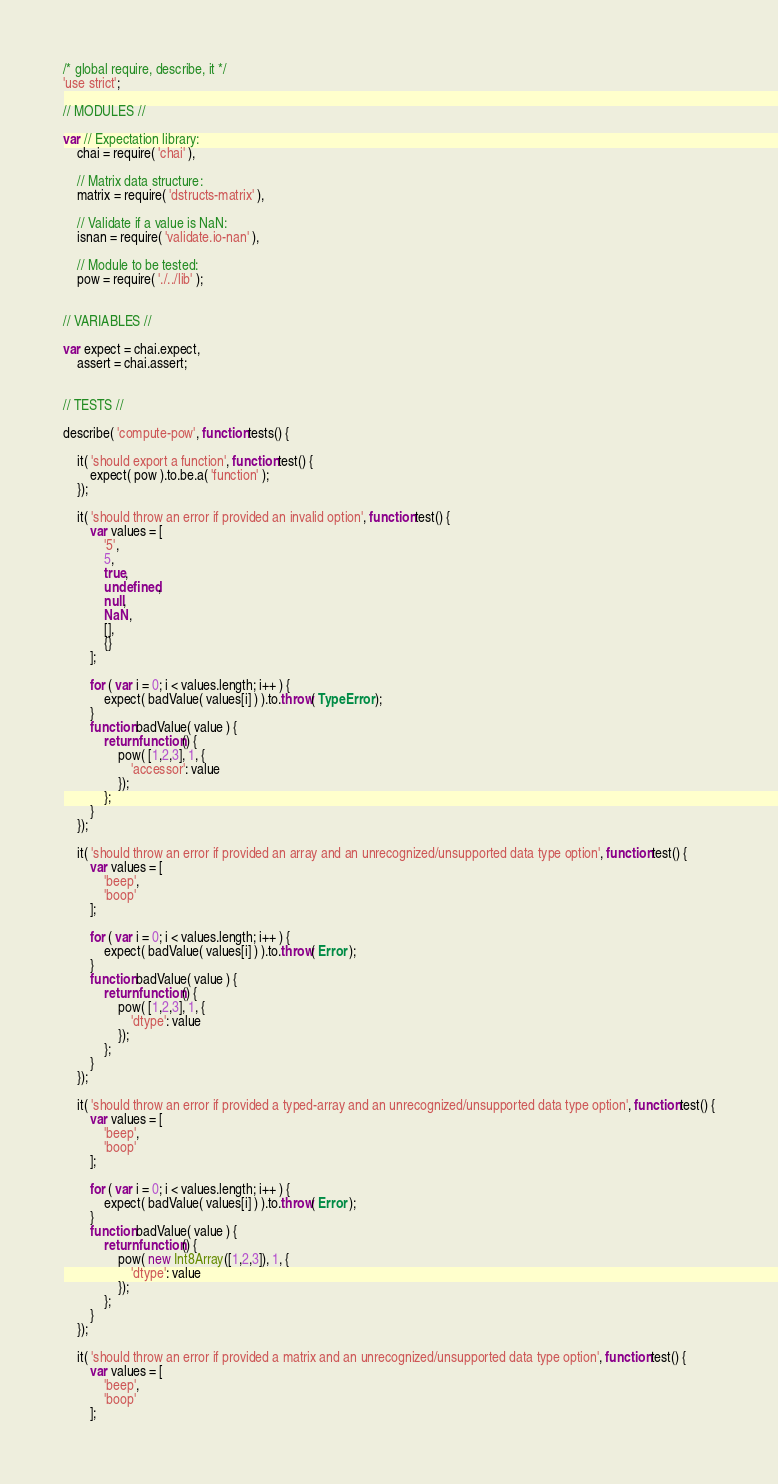Convert code to text. <code><loc_0><loc_0><loc_500><loc_500><_JavaScript_>/* global require, describe, it */
'use strict';

// MODULES //

var // Expectation library:
	chai = require( 'chai' ),

	// Matrix data structure:
	matrix = require( 'dstructs-matrix' ),

	// Validate if a value is NaN:
	isnan = require( 'validate.io-nan' ),

	// Module to be tested:
	pow = require( './../lib' );


// VARIABLES //

var expect = chai.expect,
	assert = chai.assert;


// TESTS //

describe( 'compute-pow', function tests() {

	it( 'should export a function', function test() {
		expect( pow ).to.be.a( 'function' );
	});

	it( 'should throw an error if provided an invalid option', function test() {
		var values = [
			'5',
			5,
			true,
			undefined,
			null,
			NaN,
			[],
			{}
		];

		for ( var i = 0; i < values.length; i++ ) {
			expect( badValue( values[i] ) ).to.throw( TypeError );
		}
		function badValue( value ) {
			return function() {
				pow( [1,2,3], 1, {
					'accessor': value
				});
			};
		}
	});

	it( 'should throw an error if provided an array and an unrecognized/unsupported data type option', function test() {
		var values = [
			'beep',
			'boop'
		];

		for ( var i = 0; i < values.length; i++ ) {
			expect( badValue( values[i] ) ).to.throw( Error );
		}
		function badValue( value ) {
			return function() {
				pow( [1,2,3], 1, {
					'dtype': value
				});
			};
		}
	});

	it( 'should throw an error if provided a typed-array and an unrecognized/unsupported data type option', function test() {
		var values = [
			'beep',
			'boop'
		];

		for ( var i = 0; i < values.length; i++ ) {
			expect( badValue( values[i] ) ).to.throw( Error );
		}
		function badValue( value ) {
			return function() {
				pow( new Int8Array([1,2,3]), 1, {
					'dtype': value
				});
			};
		}
	});

	it( 'should throw an error if provided a matrix and an unrecognized/unsupported data type option', function test() {
		var values = [
			'beep',
			'boop'
		];
</code> 